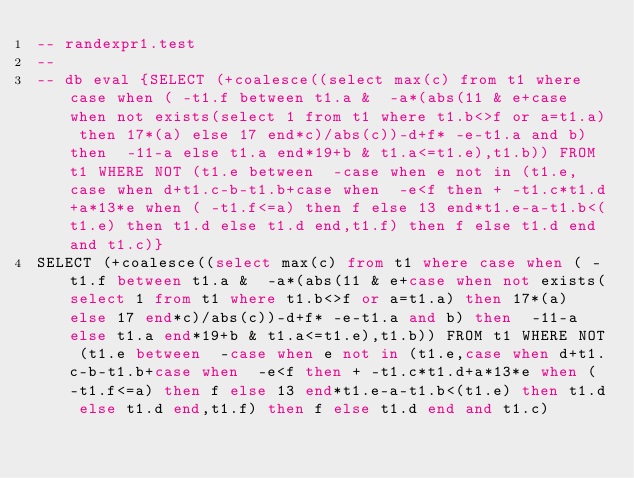Convert code to text. <code><loc_0><loc_0><loc_500><loc_500><_SQL_>-- randexpr1.test
-- 
-- db eval {SELECT (+coalesce((select max(c) from t1 where case when ( -t1.f between t1.a &  -a*(abs(11 & e+case when not exists(select 1 from t1 where t1.b<>f or a=t1.a) then 17*(a) else 17 end*c)/abs(c))-d+f* -e-t1.a and b) then  -11-a else t1.a end*19+b & t1.a<=t1.e),t1.b)) FROM t1 WHERE NOT (t1.e between  -case when e not in (t1.e,case when d+t1.c-b-t1.b+case when  -e<f then + -t1.c*t1.d+a*13*e when ( -t1.f<=a) then f else 13 end*t1.e-a-t1.b<(t1.e) then t1.d else t1.d end,t1.f) then f else t1.d end and t1.c)}
SELECT (+coalesce((select max(c) from t1 where case when ( -t1.f between t1.a &  -a*(abs(11 & e+case when not exists(select 1 from t1 where t1.b<>f or a=t1.a) then 17*(a) else 17 end*c)/abs(c))-d+f* -e-t1.a and b) then  -11-a else t1.a end*19+b & t1.a<=t1.e),t1.b)) FROM t1 WHERE NOT (t1.e between  -case when e not in (t1.e,case when d+t1.c-b-t1.b+case when  -e<f then + -t1.c*t1.d+a*13*e when ( -t1.f<=a) then f else 13 end*t1.e-a-t1.b<(t1.e) then t1.d else t1.d end,t1.f) then f else t1.d end and t1.c)</code> 